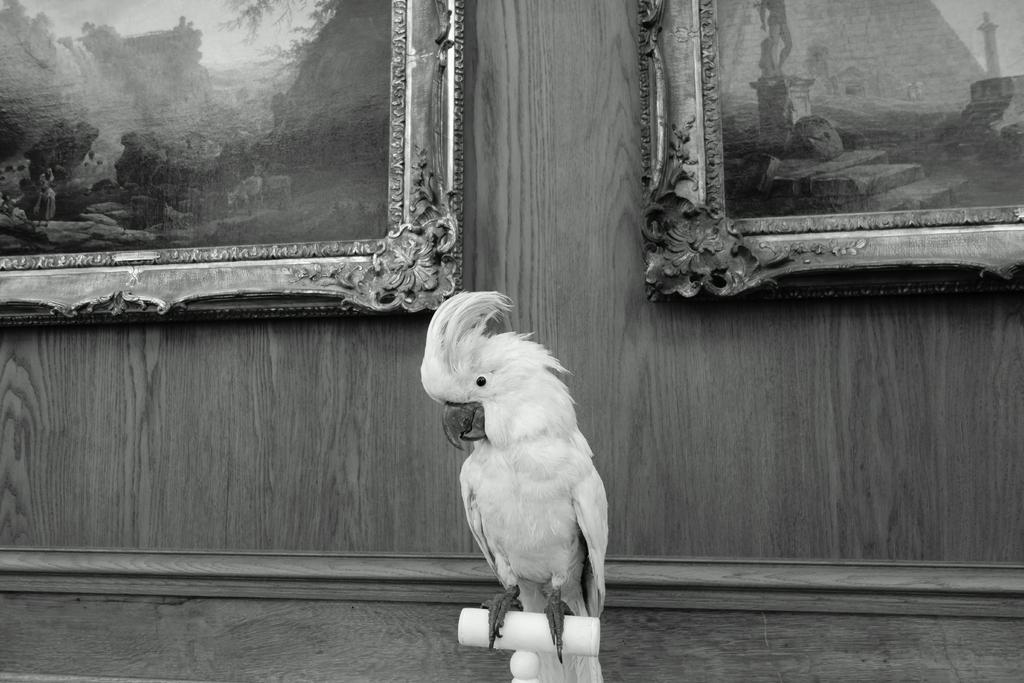In one or two sentences, can you explain what this image depicts? At the bottom of the picture, we see a white color parrot is on the white color rod. Behind that, we see a wooden wall on which two photo frames are placed. This is a black and white picture. 